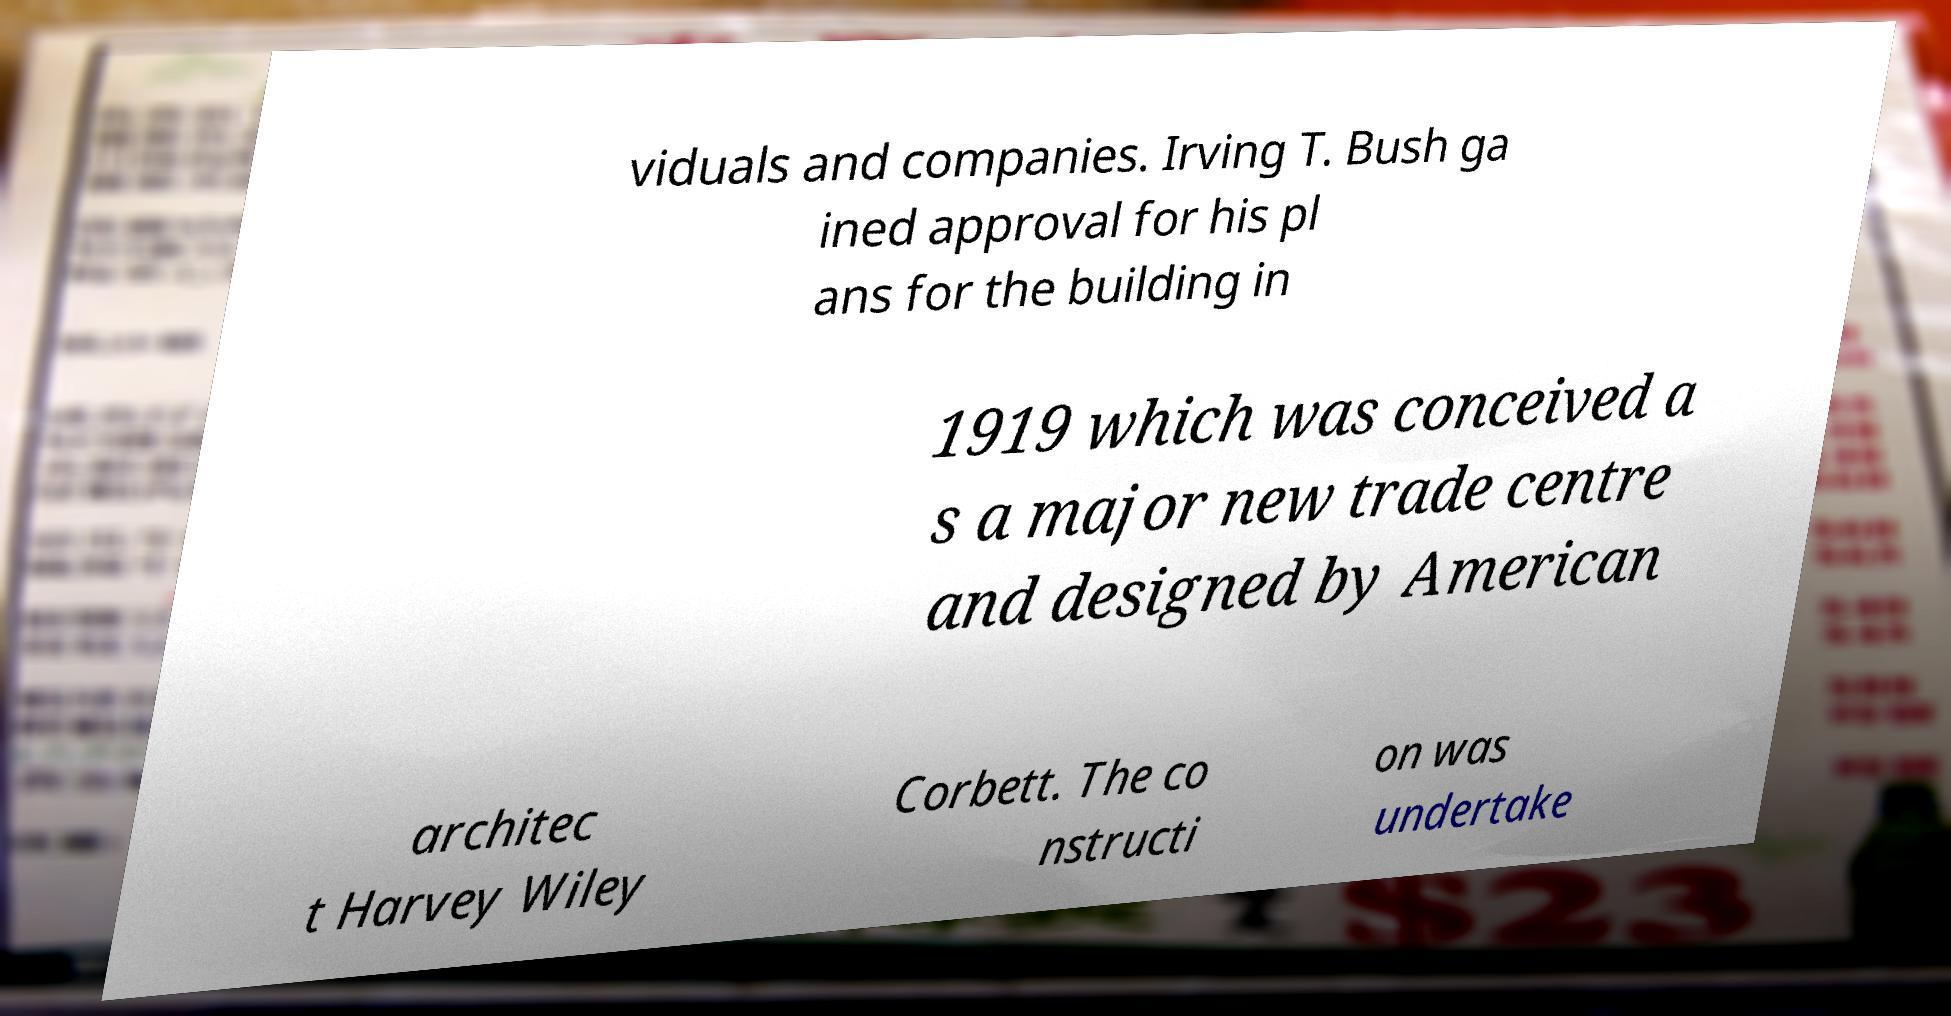Please identify and transcribe the text found in this image. viduals and companies. Irving T. Bush ga ined approval for his pl ans for the building in 1919 which was conceived a s a major new trade centre and designed by American architec t Harvey Wiley Corbett. The co nstructi on was undertake 